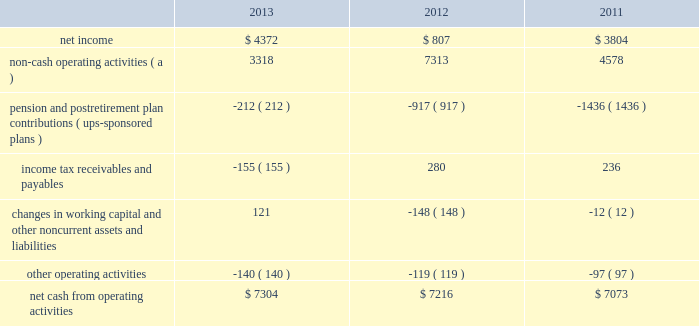United parcel service , inc .
And subsidiaries management's discussion and analysis of financial condition and results of operations liquidity and capital resources operating activities the following is a summary of the significant sources ( uses ) of cash from operating activities ( amounts in millions ) : .
( a ) represents depreciation and amortization , gains and losses on derivative and foreign exchange transactions , deferred income taxes , provisions for uncollectible accounts , pension and postretirement benefit expense , stock compensation expense , impairment charges and other non-cash items .
Cash from operating activities remained strong throughout the 2011 to 2013 time period .
Operating cash flow was favorably impacted in 2013 , compared with 2012 , by lower contributions into our defined benefit pension and postretirement benefit plans ; however , this was partially offset by certain tnt express transaction-related charges , as well as changes in income tax receivables and payables .
We paid a termination fee to tnt express of 20ac200 million ( $ 268 million ) under the agreement to terminate the merger protocol in the first quarter of 2013 .
Additionally , the cash payments for income taxes increased in 2013 compared with 2012 , and were impacted by the timing of current tax deductions .
Except for discretionary or accelerated fundings of our plans , contributions to our company-sponsored pension plans have largely varied based on whether any minimum funding requirements are present for individual pension plans .
2022 in 2013 , we did not have any required , nor make any discretionary , contributions to our primary company-sponsored pension plans in the u.s .
2022 in 2012 , we made a $ 355 million required contribution to the ups ibt pension plan .
2022 in 2011 , we made a $ 1.2 billion contribution to the ups ibt pension plan , which satisfied our 2011 contribution requirements and also approximately $ 440 million in contributions that would not have been required until after 2011 .
2022 the remaining contributions in the 2011 through 2013 period were largely due to contributions to our international pension plans and u.s .
Postretirement medical benefit plans .
As discussed further in the 201ccontractual commitments 201d section , we have minimum funding requirements in the next several years , primarily related to the ups ibt pension , ups retirement and ups pension plans .
As of december 31 , 2013 , the total of our worldwide holdings of cash and cash equivalents was $ 4.665 billion .
Approximately 45%-55% ( 45%-55 % ) of cash and cash equivalents was held by foreign subsidiaries throughout the year .
The amount of cash held by our u.s .
And foreign subsidiaries fluctuates throughout the year due to a variety of factors , including the timing of cash receipts and disbursements in the normal course of business .
Cash provided by operating activities in the united states continues to be our primary source of funds to finance domestic operating needs , capital expenditures , share repurchases and dividend payments to shareowners .
To the extent that such amounts represent previously untaxed earnings , the cash held by foreign subsidiaries would be subject to tax if such amounts were repatriated in the form of dividends ; however , not all international cash balances would have to be repatriated in the form of a dividend if returned to the u.s .
When amounts earned by foreign subsidiaries are expected to be indefinitely reinvested , no accrual for taxes is provided. .
What was the percentage change in net cash from operating activities from 2012 to 2013? 
Computations: ((7304 - 7216) / 7216)
Answer: 0.0122. 